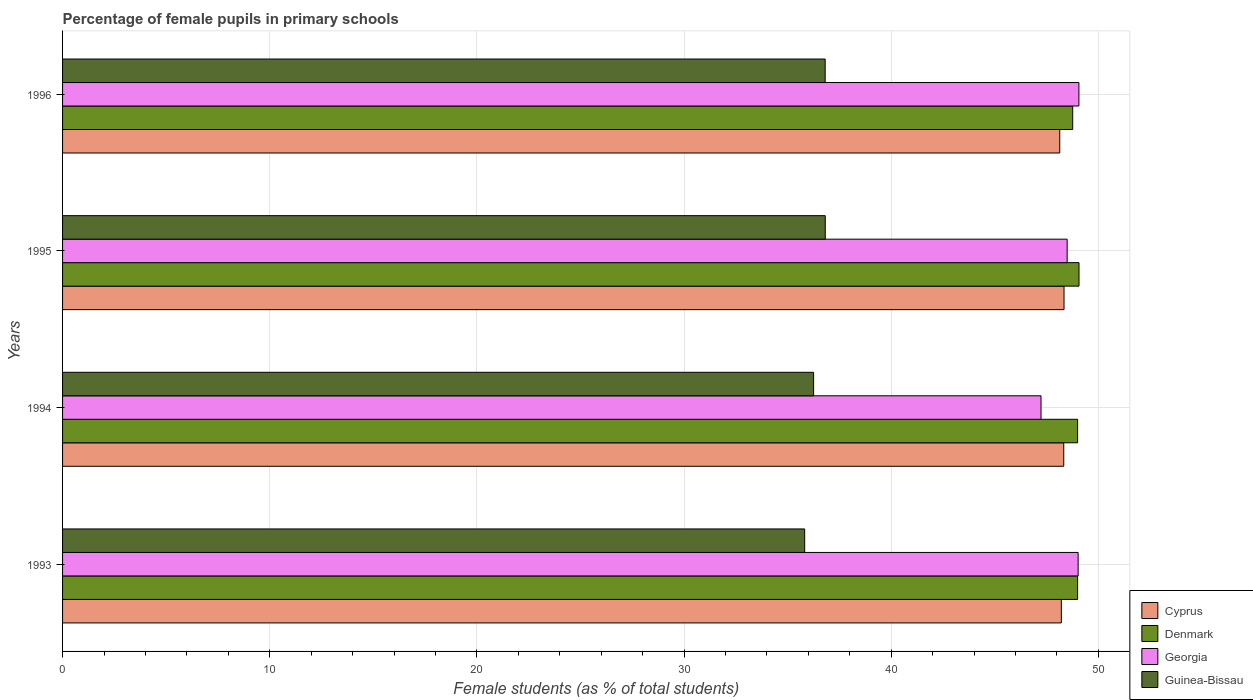How many groups of bars are there?
Give a very brief answer. 4. Are the number of bars per tick equal to the number of legend labels?
Keep it short and to the point. Yes. Are the number of bars on each tick of the Y-axis equal?
Ensure brevity in your answer.  Yes. How many bars are there on the 1st tick from the bottom?
Provide a succinct answer. 4. What is the label of the 1st group of bars from the top?
Make the answer very short. 1996. In how many cases, is the number of bars for a given year not equal to the number of legend labels?
Make the answer very short. 0. What is the percentage of female pupils in primary schools in Cyprus in 1996?
Your answer should be very brief. 48.14. Across all years, what is the maximum percentage of female pupils in primary schools in Cyprus?
Your answer should be very brief. 48.34. Across all years, what is the minimum percentage of female pupils in primary schools in Denmark?
Provide a short and direct response. 48.76. In which year was the percentage of female pupils in primary schools in Georgia minimum?
Provide a short and direct response. 1994. What is the total percentage of female pupils in primary schools in Cyprus in the graph?
Your answer should be very brief. 193.03. What is the difference between the percentage of female pupils in primary schools in Georgia in 1993 and that in 1994?
Offer a very short reply. 1.79. What is the difference between the percentage of female pupils in primary schools in Denmark in 1993 and the percentage of female pupils in primary schools in Georgia in 1994?
Offer a very short reply. 1.77. What is the average percentage of female pupils in primary schools in Georgia per year?
Give a very brief answer. 48.45. In the year 1995, what is the difference between the percentage of female pupils in primary schools in Guinea-Bissau and percentage of female pupils in primary schools in Denmark?
Offer a terse response. -12.25. In how many years, is the percentage of female pupils in primary schools in Denmark greater than 26 %?
Give a very brief answer. 4. What is the ratio of the percentage of female pupils in primary schools in Cyprus in 1994 to that in 1995?
Give a very brief answer. 1. Is the percentage of female pupils in primary schools in Guinea-Bissau in 1993 less than that in 1995?
Your answer should be very brief. Yes. What is the difference between the highest and the second highest percentage of female pupils in primary schools in Denmark?
Your answer should be very brief. 0.07. What is the difference between the highest and the lowest percentage of female pupils in primary schools in Denmark?
Provide a short and direct response. 0.3. In how many years, is the percentage of female pupils in primary schools in Denmark greater than the average percentage of female pupils in primary schools in Denmark taken over all years?
Give a very brief answer. 3. Is the sum of the percentage of female pupils in primary schools in Guinea-Bissau in 1993 and 1996 greater than the maximum percentage of female pupils in primary schools in Georgia across all years?
Keep it short and to the point. Yes. Is it the case that in every year, the sum of the percentage of female pupils in primary schools in Guinea-Bissau and percentage of female pupils in primary schools in Cyprus is greater than the sum of percentage of female pupils in primary schools in Georgia and percentage of female pupils in primary schools in Denmark?
Provide a short and direct response. No. What does the 1st bar from the top in 1995 represents?
Make the answer very short. Guinea-Bissau. What does the 3rd bar from the bottom in 1994 represents?
Give a very brief answer. Georgia. Are all the bars in the graph horizontal?
Your answer should be very brief. Yes. What is the difference between two consecutive major ticks on the X-axis?
Offer a very short reply. 10. Does the graph contain grids?
Ensure brevity in your answer.  Yes. How many legend labels are there?
Offer a very short reply. 4. What is the title of the graph?
Keep it short and to the point. Percentage of female pupils in primary schools. Does "Romania" appear as one of the legend labels in the graph?
Give a very brief answer. No. What is the label or title of the X-axis?
Give a very brief answer. Female students (as % of total students). What is the label or title of the Y-axis?
Keep it short and to the point. Years. What is the Female students (as % of total students) of Cyprus in 1993?
Keep it short and to the point. 48.21. What is the Female students (as % of total students) in Denmark in 1993?
Give a very brief answer. 49. What is the Female students (as % of total students) in Georgia in 1993?
Make the answer very short. 49.03. What is the Female students (as % of total students) of Guinea-Bissau in 1993?
Provide a short and direct response. 35.83. What is the Female students (as % of total students) in Cyprus in 1994?
Keep it short and to the point. 48.33. What is the Female students (as % of total students) of Denmark in 1994?
Provide a succinct answer. 49. What is the Female students (as % of total students) of Georgia in 1994?
Ensure brevity in your answer.  47.23. What is the Female students (as % of total students) in Guinea-Bissau in 1994?
Give a very brief answer. 36.26. What is the Female students (as % of total students) in Cyprus in 1995?
Your answer should be compact. 48.34. What is the Female students (as % of total students) of Denmark in 1995?
Offer a terse response. 49.07. What is the Female students (as % of total students) of Georgia in 1995?
Your answer should be compact. 48.5. What is the Female students (as % of total students) in Guinea-Bissau in 1995?
Your answer should be very brief. 36.82. What is the Female students (as % of total students) of Cyprus in 1996?
Offer a terse response. 48.14. What is the Female students (as % of total students) of Denmark in 1996?
Keep it short and to the point. 48.76. What is the Female students (as % of total students) of Georgia in 1996?
Keep it short and to the point. 49.06. What is the Female students (as % of total students) of Guinea-Bissau in 1996?
Your response must be concise. 36.81. Across all years, what is the maximum Female students (as % of total students) of Cyprus?
Make the answer very short. 48.34. Across all years, what is the maximum Female students (as % of total students) in Denmark?
Offer a terse response. 49.07. Across all years, what is the maximum Female students (as % of total students) in Georgia?
Offer a terse response. 49.06. Across all years, what is the maximum Female students (as % of total students) in Guinea-Bissau?
Your answer should be compact. 36.82. Across all years, what is the minimum Female students (as % of total students) of Cyprus?
Your answer should be compact. 48.14. Across all years, what is the minimum Female students (as % of total students) in Denmark?
Provide a succinct answer. 48.76. Across all years, what is the minimum Female students (as % of total students) of Georgia?
Keep it short and to the point. 47.23. Across all years, what is the minimum Female students (as % of total students) in Guinea-Bissau?
Ensure brevity in your answer.  35.83. What is the total Female students (as % of total students) of Cyprus in the graph?
Make the answer very short. 193.03. What is the total Female students (as % of total students) of Denmark in the graph?
Offer a terse response. 195.83. What is the total Female students (as % of total students) in Georgia in the graph?
Your response must be concise. 193.82. What is the total Female students (as % of total students) of Guinea-Bissau in the graph?
Your response must be concise. 145.71. What is the difference between the Female students (as % of total students) of Cyprus in 1993 and that in 1994?
Keep it short and to the point. -0.12. What is the difference between the Female students (as % of total students) in Georgia in 1993 and that in 1994?
Ensure brevity in your answer.  1.79. What is the difference between the Female students (as % of total students) of Guinea-Bissau in 1993 and that in 1994?
Provide a succinct answer. -0.43. What is the difference between the Female students (as % of total students) in Cyprus in 1993 and that in 1995?
Offer a terse response. -0.13. What is the difference between the Female students (as % of total students) of Denmark in 1993 and that in 1995?
Offer a terse response. -0.07. What is the difference between the Female students (as % of total students) in Georgia in 1993 and that in 1995?
Give a very brief answer. 0.53. What is the difference between the Female students (as % of total students) of Guinea-Bissau in 1993 and that in 1995?
Your response must be concise. -0.99. What is the difference between the Female students (as % of total students) in Cyprus in 1993 and that in 1996?
Your response must be concise. 0.08. What is the difference between the Female students (as % of total students) of Denmark in 1993 and that in 1996?
Offer a very short reply. 0.24. What is the difference between the Female students (as % of total students) in Georgia in 1993 and that in 1996?
Offer a very short reply. -0.04. What is the difference between the Female students (as % of total students) in Guinea-Bissau in 1993 and that in 1996?
Your answer should be compact. -0.99. What is the difference between the Female students (as % of total students) of Cyprus in 1994 and that in 1995?
Offer a terse response. -0.01. What is the difference between the Female students (as % of total students) in Denmark in 1994 and that in 1995?
Your response must be concise. -0.07. What is the difference between the Female students (as % of total students) in Georgia in 1994 and that in 1995?
Give a very brief answer. -1.26. What is the difference between the Female students (as % of total students) of Guinea-Bissau in 1994 and that in 1995?
Your answer should be compact. -0.56. What is the difference between the Female students (as % of total students) in Cyprus in 1994 and that in 1996?
Your response must be concise. 0.19. What is the difference between the Female students (as % of total students) of Denmark in 1994 and that in 1996?
Provide a short and direct response. 0.24. What is the difference between the Female students (as % of total students) in Georgia in 1994 and that in 1996?
Keep it short and to the point. -1.83. What is the difference between the Female students (as % of total students) in Guinea-Bissau in 1994 and that in 1996?
Your answer should be very brief. -0.56. What is the difference between the Female students (as % of total students) in Cyprus in 1995 and that in 1996?
Provide a short and direct response. 0.21. What is the difference between the Female students (as % of total students) in Denmark in 1995 and that in 1996?
Keep it short and to the point. 0.3. What is the difference between the Female students (as % of total students) in Georgia in 1995 and that in 1996?
Keep it short and to the point. -0.57. What is the difference between the Female students (as % of total students) in Guinea-Bissau in 1995 and that in 1996?
Offer a very short reply. 0. What is the difference between the Female students (as % of total students) in Cyprus in 1993 and the Female students (as % of total students) in Denmark in 1994?
Offer a very short reply. -0.79. What is the difference between the Female students (as % of total students) in Cyprus in 1993 and the Female students (as % of total students) in Georgia in 1994?
Your response must be concise. 0.98. What is the difference between the Female students (as % of total students) of Cyprus in 1993 and the Female students (as % of total students) of Guinea-Bissau in 1994?
Your answer should be very brief. 11.96. What is the difference between the Female students (as % of total students) of Denmark in 1993 and the Female students (as % of total students) of Georgia in 1994?
Provide a short and direct response. 1.77. What is the difference between the Female students (as % of total students) of Denmark in 1993 and the Female students (as % of total students) of Guinea-Bissau in 1994?
Provide a succinct answer. 12.74. What is the difference between the Female students (as % of total students) in Georgia in 1993 and the Female students (as % of total students) in Guinea-Bissau in 1994?
Offer a terse response. 12.77. What is the difference between the Female students (as % of total students) in Cyprus in 1993 and the Female students (as % of total students) in Denmark in 1995?
Offer a very short reply. -0.85. What is the difference between the Female students (as % of total students) in Cyprus in 1993 and the Female students (as % of total students) in Georgia in 1995?
Your answer should be compact. -0.28. What is the difference between the Female students (as % of total students) of Cyprus in 1993 and the Female students (as % of total students) of Guinea-Bissau in 1995?
Your answer should be compact. 11.4. What is the difference between the Female students (as % of total students) of Denmark in 1993 and the Female students (as % of total students) of Georgia in 1995?
Your answer should be compact. 0.51. What is the difference between the Female students (as % of total students) in Denmark in 1993 and the Female students (as % of total students) in Guinea-Bissau in 1995?
Offer a terse response. 12.18. What is the difference between the Female students (as % of total students) of Georgia in 1993 and the Female students (as % of total students) of Guinea-Bissau in 1995?
Your answer should be compact. 12.21. What is the difference between the Female students (as % of total students) of Cyprus in 1993 and the Female students (as % of total students) of Denmark in 1996?
Provide a succinct answer. -0.55. What is the difference between the Female students (as % of total students) of Cyprus in 1993 and the Female students (as % of total students) of Georgia in 1996?
Provide a succinct answer. -0.85. What is the difference between the Female students (as % of total students) in Cyprus in 1993 and the Female students (as % of total students) in Guinea-Bissau in 1996?
Offer a terse response. 11.4. What is the difference between the Female students (as % of total students) of Denmark in 1993 and the Female students (as % of total students) of Georgia in 1996?
Provide a succinct answer. -0.06. What is the difference between the Female students (as % of total students) of Denmark in 1993 and the Female students (as % of total students) of Guinea-Bissau in 1996?
Your answer should be compact. 12.19. What is the difference between the Female students (as % of total students) of Georgia in 1993 and the Female students (as % of total students) of Guinea-Bissau in 1996?
Keep it short and to the point. 12.21. What is the difference between the Female students (as % of total students) in Cyprus in 1994 and the Female students (as % of total students) in Denmark in 1995?
Offer a terse response. -0.74. What is the difference between the Female students (as % of total students) of Cyprus in 1994 and the Female students (as % of total students) of Georgia in 1995?
Ensure brevity in your answer.  -0.16. What is the difference between the Female students (as % of total students) in Cyprus in 1994 and the Female students (as % of total students) in Guinea-Bissau in 1995?
Keep it short and to the point. 11.51. What is the difference between the Female students (as % of total students) in Denmark in 1994 and the Female students (as % of total students) in Georgia in 1995?
Provide a short and direct response. 0.5. What is the difference between the Female students (as % of total students) of Denmark in 1994 and the Female students (as % of total students) of Guinea-Bissau in 1995?
Ensure brevity in your answer.  12.18. What is the difference between the Female students (as % of total students) in Georgia in 1994 and the Female students (as % of total students) in Guinea-Bissau in 1995?
Ensure brevity in your answer.  10.42. What is the difference between the Female students (as % of total students) in Cyprus in 1994 and the Female students (as % of total students) in Denmark in 1996?
Ensure brevity in your answer.  -0.43. What is the difference between the Female students (as % of total students) in Cyprus in 1994 and the Female students (as % of total students) in Georgia in 1996?
Provide a succinct answer. -0.73. What is the difference between the Female students (as % of total students) in Cyprus in 1994 and the Female students (as % of total students) in Guinea-Bissau in 1996?
Your response must be concise. 11.52. What is the difference between the Female students (as % of total students) in Denmark in 1994 and the Female students (as % of total students) in Georgia in 1996?
Offer a terse response. -0.06. What is the difference between the Female students (as % of total students) in Denmark in 1994 and the Female students (as % of total students) in Guinea-Bissau in 1996?
Offer a terse response. 12.19. What is the difference between the Female students (as % of total students) in Georgia in 1994 and the Female students (as % of total students) in Guinea-Bissau in 1996?
Provide a succinct answer. 10.42. What is the difference between the Female students (as % of total students) of Cyprus in 1995 and the Female students (as % of total students) of Denmark in 1996?
Ensure brevity in your answer.  -0.42. What is the difference between the Female students (as % of total students) of Cyprus in 1995 and the Female students (as % of total students) of Georgia in 1996?
Your answer should be very brief. -0.72. What is the difference between the Female students (as % of total students) of Cyprus in 1995 and the Female students (as % of total students) of Guinea-Bissau in 1996?
Your answer should be very brief. 11.53. What is the difference between the Female students (as % of total students) in Denmark in 1995 and the Female students (as % of total students) in Georgia in 1996?
Your response must be concise. 0.01. What is the difference between the Female students (as % of total students) in Denmark in 1995 and the Female students (as % of total students) in Guinea-Bissau in 1996?
Ensure brevity in your answer.  12.25. What is the difference between the Female students (as % of total students) of Georgia in 1995 and the Female students (as % of total students) of Guinea-Bissau in 1996?
Provide a short and direct response. 11.68. What is the average Female students (as % of total students) of Cyprus per year?
Provide a short and direct response. 48.26. What is the average Female students (as % of total students) of Denmark per year?
Give a very brief answer. 48.96. What is the average Female students (as % of total students) of Georgia per year?
Ensure brevity in your answer.  48.45. What is the average Female students (as % of total students) in Guinea-Bissau per year?
Provide a succinct answer. 36.43. In the year 1993, what is the difference between the Female students (as % of total students) of Cyprus and Female students (as % of total students) of Denmark?
Offer a very short reply. -0.79. In the year 1993, what is the difference between the Female students (as % of total students) in Cyprus and Female students (as % of total students) in Georgia?
Your answer should be very brief. -0.81. In the year 1993, what is the difference between the Female students (as % of total students) in Cyprus and Female students (as % of total students) in Guinea-Bissau?
Ensure brevity in your answer.  12.39. In the year 1993, what is the difference between the Female students (as % of total students) of Denmark and Female students (as % of total students) of Georgia?
Keep it short and to the point. -0.03. In the year 1993, what is the difference between the Female students (as % of total students) in Denmark and Female students (as % of total students) in Guinea-Bissau?
Your answer should be very brief. 13.17. In the year 1993, what is the difference between the Female students (as % of total students) in Georgia and Female students (as % of total students) in Guinea-Bissau?
Your answer should be compact. 13.2. In the year 1994, what is the difference between the Female students (as % of total students) of Cyprus and Female students (as % of total students) of Denmark?
Your answer should be very brief. -0.67. In the year 1994, what is the difference between the Female students (as % of total students) in Cyprus and Female students (as % of total students) in Georgia?
Provide a succinct answer. 1.1. In the year 1994, what is the difference between the Female students (as % of total students) of Cyprus and Female students (as % of total students) of Guinea-Bissau?
Provide a succinct answer. 12.07. In the year 1994, what is the difference between the Female students (as % of total students) in Denmark and Female students (as % of total students) in Georgia?
Keep it short and to the point. 1.77. In the year 1994, what is the difference between the Female students (as % of total students) in Denmark and Female students (as % of total students) in Guinea-Bissau?
Give a very brief answer. 12.74. In the year 1994, what is the difference between the Female students (as % of total students) in Georgia and Female students (as % of total students) in Guinea-Bissau?
Your answer should be compact. 10.98. In the year 1995, what is the difference between the Female students (as % of total students) of Cyprus and Female students (as % of total students) of Denmark?
Offer a very short reply. -0.72. In the year 1995, what is the difference between the Female students (as % of total students) of Cyprus and Female students (as % of total students) of Georgia?
Your response must be concise. -0.15. In the year 1995, what is the difference between the Female students (as % of total students) in Cyprus and Female students (as % of total students) in Guinea-Bissau?
Ensure brevity in your answer.  11.53. In the year 1995, what is the difference between the Female students (as % of total students) in Denmark and Female students (as % of total students) in Georgia?
Ensure brevity in your answer.  0.57. In the year 1995, what is the difference between the Female students (as % of total students) in Denmark and Female students (as % of total students) in Guinea-Bissau?
Your answer should be compact. 12.25. In the year 1995, what is the difference between the Female students (as % of total students) in Georgia and Female students (as % of total students) in Guinea-Bissau?
Give a very brief answer. 11.68. In the year 1996, what is the difference between the Female students (as % of total students) of Cyprus and Female students (as % of total students) of Denmark?
Your answer should be very brief. -0.63. In the year 1996, what is the difference between the Female students (as % of total students) in Cyprus and Female students (as % of total students) in Georgia?
Offer a very short reply. -0.92. In the year 1996, what is the difference between the Female students (as % of total students) in Cyprus and Female students (as % of total students) in Guinea-Bissau?
Provide a short and direct response. 11.32. In the year 1996, what is the difference between the Female students (as % of total students) in Denmark and Female students (as % of total students) in Georgia?
Offer a very short reply. -0.3. In the year 1996, what is the difference between the Female students (as % of total students) of Denmark and Female students (as % of total students) of Guinea-Bissau?
Give a very brief answer. 11.95. In the year 1996, what is the difference between the Female students (as % of total students) of Georgia and Female students (as % of total students) of Guinea-Bissau?
Offer a very short reply. 12.25. What is the ratio of the Female students (as % of total students) in Denmark in 1993 to that in 1994?
Your answer should be very brief. 1. What is the ratio of the Female students (as % of total students) of Georgia in 1993 to that in 1994?
Ensure brevity in your answer.  1.04. What is the ratio of the Female students (as % of total students) of Denmark in 1993 to that in 1995?
Offer a very short reply. 1. What is the ratio of the Female students (as % of total students) in Georgia in 1993 to that in 1995?
Your answer should be compact. 1.01. What is the ratio of the Female students (as % of total students) in Guinea-Bissau in 1993 to that in 1995?
Offer a terse response. 0.97. What is the ratio of the Female students (as % of total students) in Cyprus in 1993 to that in 1996?
Offer a terse response. 1. What is the ratio of the Female students (as % of total students) in Georgia in 1993 to that in 1996?
Provide a short and direct response. 1. What is the ratio of the Female students (as % of total students) in Guinea-Bissau in 1993 to that in 1996?
Offer a terse response. 0.97. What is the ratio of the Female students (as % of total students) in Denmark in 1994 to that in 1995?
Offer a very short reply. 1. What is the ratio of the Female students (as % of total students) of Georgia in 1994 to that in 1995?
Ensure brevity in your answer.  0.97. What is the ratio of the Female students (as % of total students) in Guinea-Bissau in 1994 to that in 1995?
Give a very brief answer. 0.98. What is the ratio of the Female students (as % of total students) of Cyprus in 1994 to that in 1996?
Make the answer very short. 1. What is the ratio of the Female students (as % of total students) of Georgia in 1994 to that in 1996?
Your answer should be very brief. 0.96. What is the ratio of the Female students (as % of total students) in Denmark in 1995 to that in 1996?
Offer a very short reply. 1.01. What is the ratio of the Female students (as % of total students) in Georgia in 1995 to that in 1996?
Your response must be concise. 0.99. What is the difference between the highest and the second highest Female students (as % of total students) in Cyprus?
Make the answer very short. 0.01. What is the difference between the highest and the second highest Female students (as % of total students) in Denmark?
Make the answer very short. 0.07. What is the difference between the highest and the second highest Female students (as % of total students) of Georgia?
Your answer should be compact. 0.04. What is the difference between the highest and the second highest Female students (as % of total students) in Guinea-Bissau?
Give a very brief answer. 0. What is the difference between the highest and the lowest Female students (as % of total students) in Cyprus?
Give a very brief answer. 0.21. What is the difference between the highest and the lowest Female students (as % of total students) in Denmark?
Provide a short and direct response. 0.3. What is the difference between the highest and the lowest Female students (as % of total students) of Georgia?
Ensure brevity in your answer.  1.83. What is the difference between the highest and the lowest Female students (as % of total students) in Guinea-Bissau?
Ensure brevity in your answer.  0.99. 